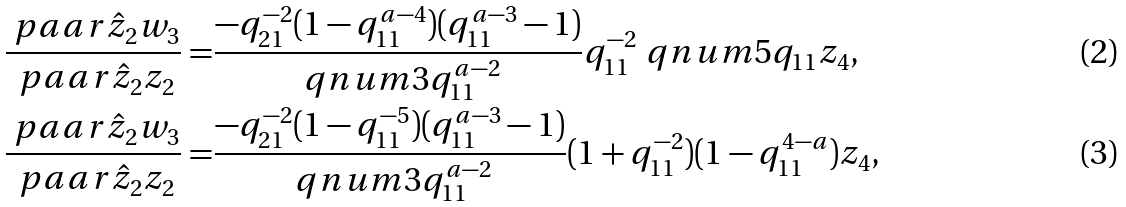Convert formula to latex. <formula><loc_0><loc_0><loc_500><loc_500>\frac { \ p a a r { \hat { z } _ { 2 } } { w _ { 3 } } } { \ p a a r { \hat { z } _ { 2 } } { z _ { 2 } } } = & \frac { - q _ { 2 1 } ^ { - 2 } ( 1 - q _ { 1 1 } ^ { a - 4 } ) ( q _ { 1 1 } ^ { a - 3 } - 1 ) } { \ q n u m { 3 } { q _ { 1 1 } ^ { a - 2 } } } q _ { 1 1 } ^ { - 2 } \ q n u m { 5 } { q _ { 1 1 } } z _ { 4 } , \\ \frac { \ p a a r { \hat { z } _ { 2 } } { w _ { 3 } } } { \ p a a r { \hat { z } _ { 2 } } { z _ { 2 } } } = & \frac { - q _ { 2 1 } ^ { - 2 } ( 1 - q _ { 1 1 } ^ { - 5 } ) ( q _ { 1 1 } ^ { a - 3 } - 1 ) } { \ q n u m { 3 } { q _ { 1 1 } ^ { a - 2 } } } ( 1 + q _ { 1 1 } ^ { - 2 } ) ( 1 - q _ { 1 1 } ^ { 4 - a } ) z _ { 4 } ,</formula> 